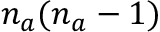Convert formula to latex. <formula><loc_0><loc_0><loc_500><loc_500>n _ { a } ( n _ { a } - 1 )</formula> 